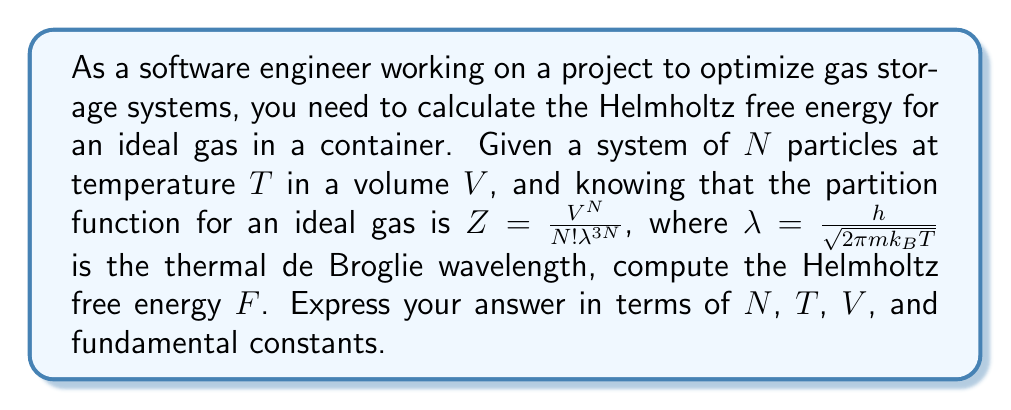Give your solution to this math problem. Let's approach this step-by-step:

1) The Helmholtz free energy $F$ is related to the partition function $Z$ by the equation:

   $$F = -k_B T \ln Z$$

2) We are given the partition function for an ideal gas:

   $$Z = \frac{V^N}{N! \lambda^{3N}}$$

3) Substituting this into the equation for $F$:

   $$F = -k_B T \ln \left(\frac{V^N}{N! \lambda^{3N}}\right)$$

4) Using the properties of logarithms:

   $$F = -k_B T \left[N \ln V - \ln(N!) - 3N \ln \lambda\right]$$

5) We can use Stirling's approximation for large $N$: $\ln(N!) \approx N \ln N - N$

   $$F \approx -k_B T \left[N \ln V - (N \ln N - N) - 3N \ln \lambda\right]$$

6) Simplifying:

   $$F \approx -k_B T \left[N \ln V - N \ln N + N - 3N \ln \lambda\right]$$
   $$F \approx -k_B T N \left[\ln \left(\frac{V}{N}\right) + 1 - 3 \ln \lambda\right]$$

7) Recall that $\lambda = \frac{h}{\sqrt{2\pi m k_B T}}$. Let's substitute this:

   $$F \approx -k_B T N \left[\ln \left(\frac{V}{N}\right) + 1 - 3 \ln \left(\frac{h}{\sqrt{2\pi m k_B T}}\right)\right]$$

8) Simplifying the logarithm term:

   $$F \approx -k_B T N \left[\ln \left(\frac{V}{N}\right) + 1 - 3 \ln h + \frac{3}{2} \ln (2\pi m k_B T)\right]$$

This is the final expression for the Helmholtz free energy of an ideal gas in terms of $N$, $T$, $V$, and fundamental constants.
Answer: $$F \approx -k_B T N \left[\ln \left(\frac{V}{N}\right) + 1 - 3 \ln h + \frac{3}{2} \ln (2\pi m k_B T)\right]$$ 